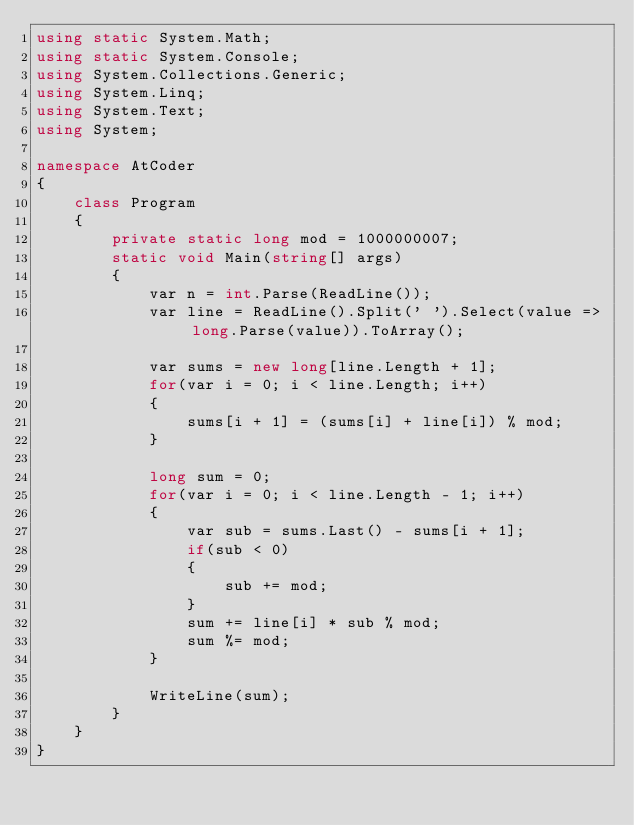<code> <loc_0><loc_0><loc_500><loc_500><_C#_>using static System.Math;
using static System.Console;
using System.Collections.Generic;
using System.Linq;
using System.Text;
using System;

namespace AtCoder
{
    class Program
    {
        private static long mod = 1000000007;
        static void Main(string[] args)
        {
            var n = int.Parse(ReadLine());
            var line = ReadLine().Split(' ').Select(value => long.Parse(value)).ToArray();

            var sums = new long[line.Length + 1];
            for(var i = 0; i < line.Length; i++)
            {
                sums[i + 1] = (sums[i] + line[i]) % mod;
            }

            long sum = 0;
            for(var i = 0; i < line.Length - 1; i++)
            {
                var sub = sums.Last() - sums[i + 1];
                if(sub < 0)
                {
                    sub += mod;
                }
                sum += line[i] * sub % mod;
                sum %= mod;
            }

            WriteLine(sum);
        }
    }
}</code> 